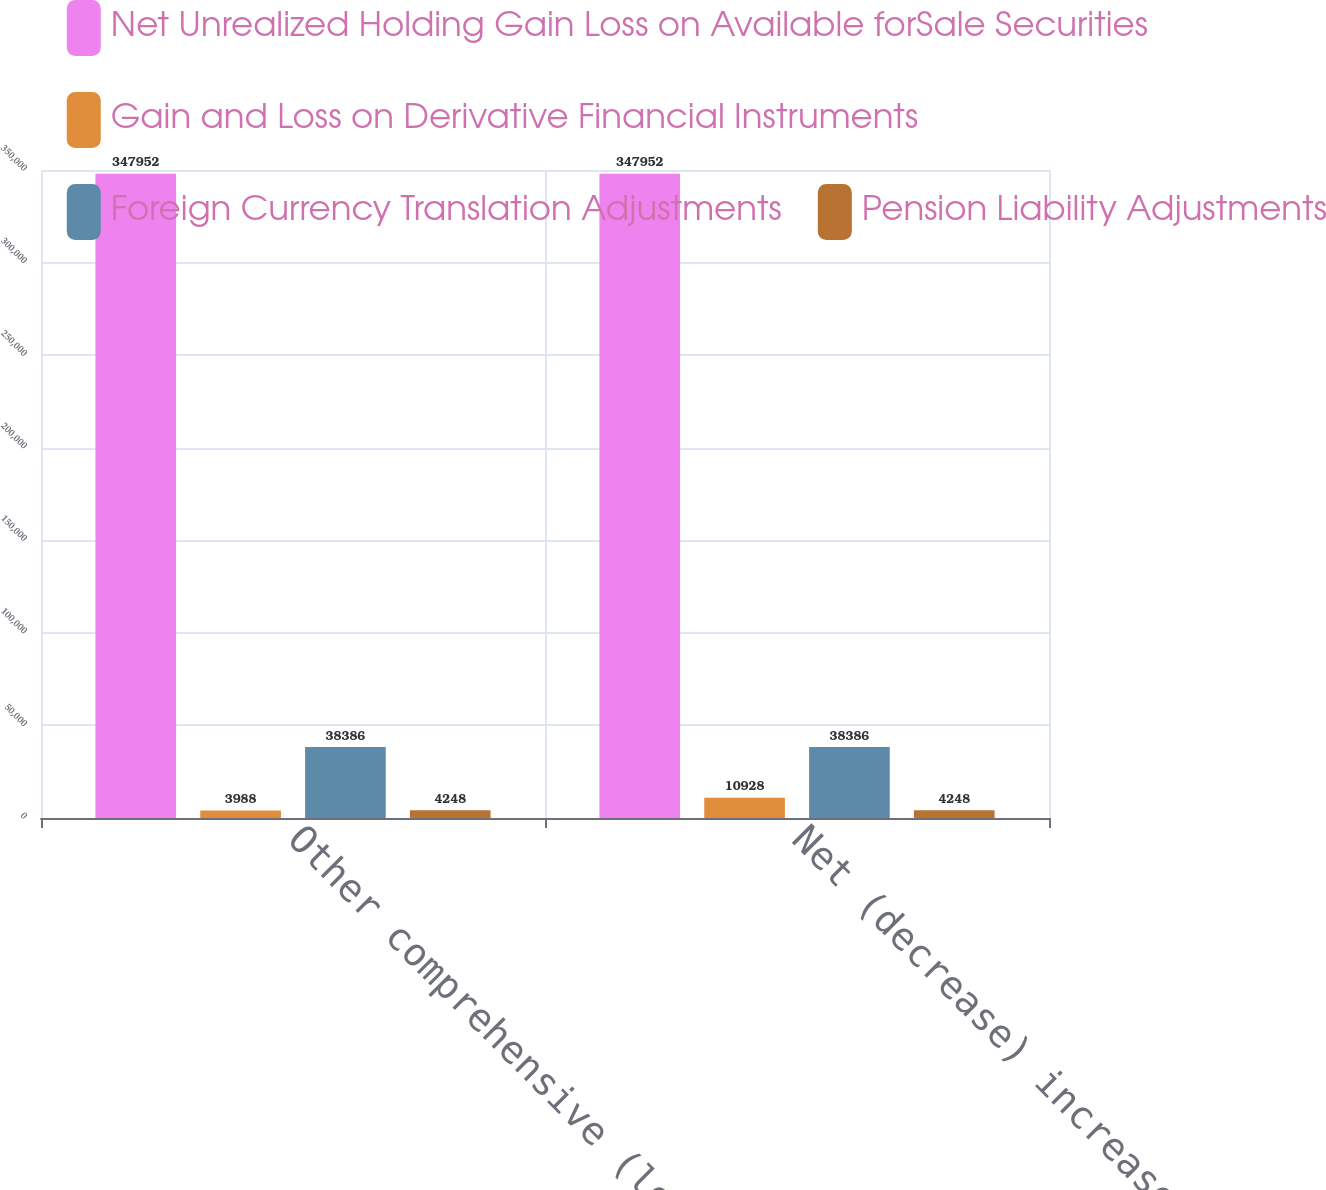<chart> <loc_0><loc_0><loc_500><loc_500><stacked_bar_chart><ecel><fcel>Other comprehensive (loss)<fcel>Net (decrease) increase in<nl><fcel>Net Unrealized Holding Gain Loss on Available forSale Securities<fcel>347952<fcel>347952<nl><fcel>Gain and Loss on Derivative Financial Instruments<fcel>3988<fcel>10928<nl><fcel>Foreign Currency Translation Adjustments<fcel>38386<fcel>38386<nl><fcel>Pension Liability Adjustments<fcel>4248<fcel>4248<nl></chart> 